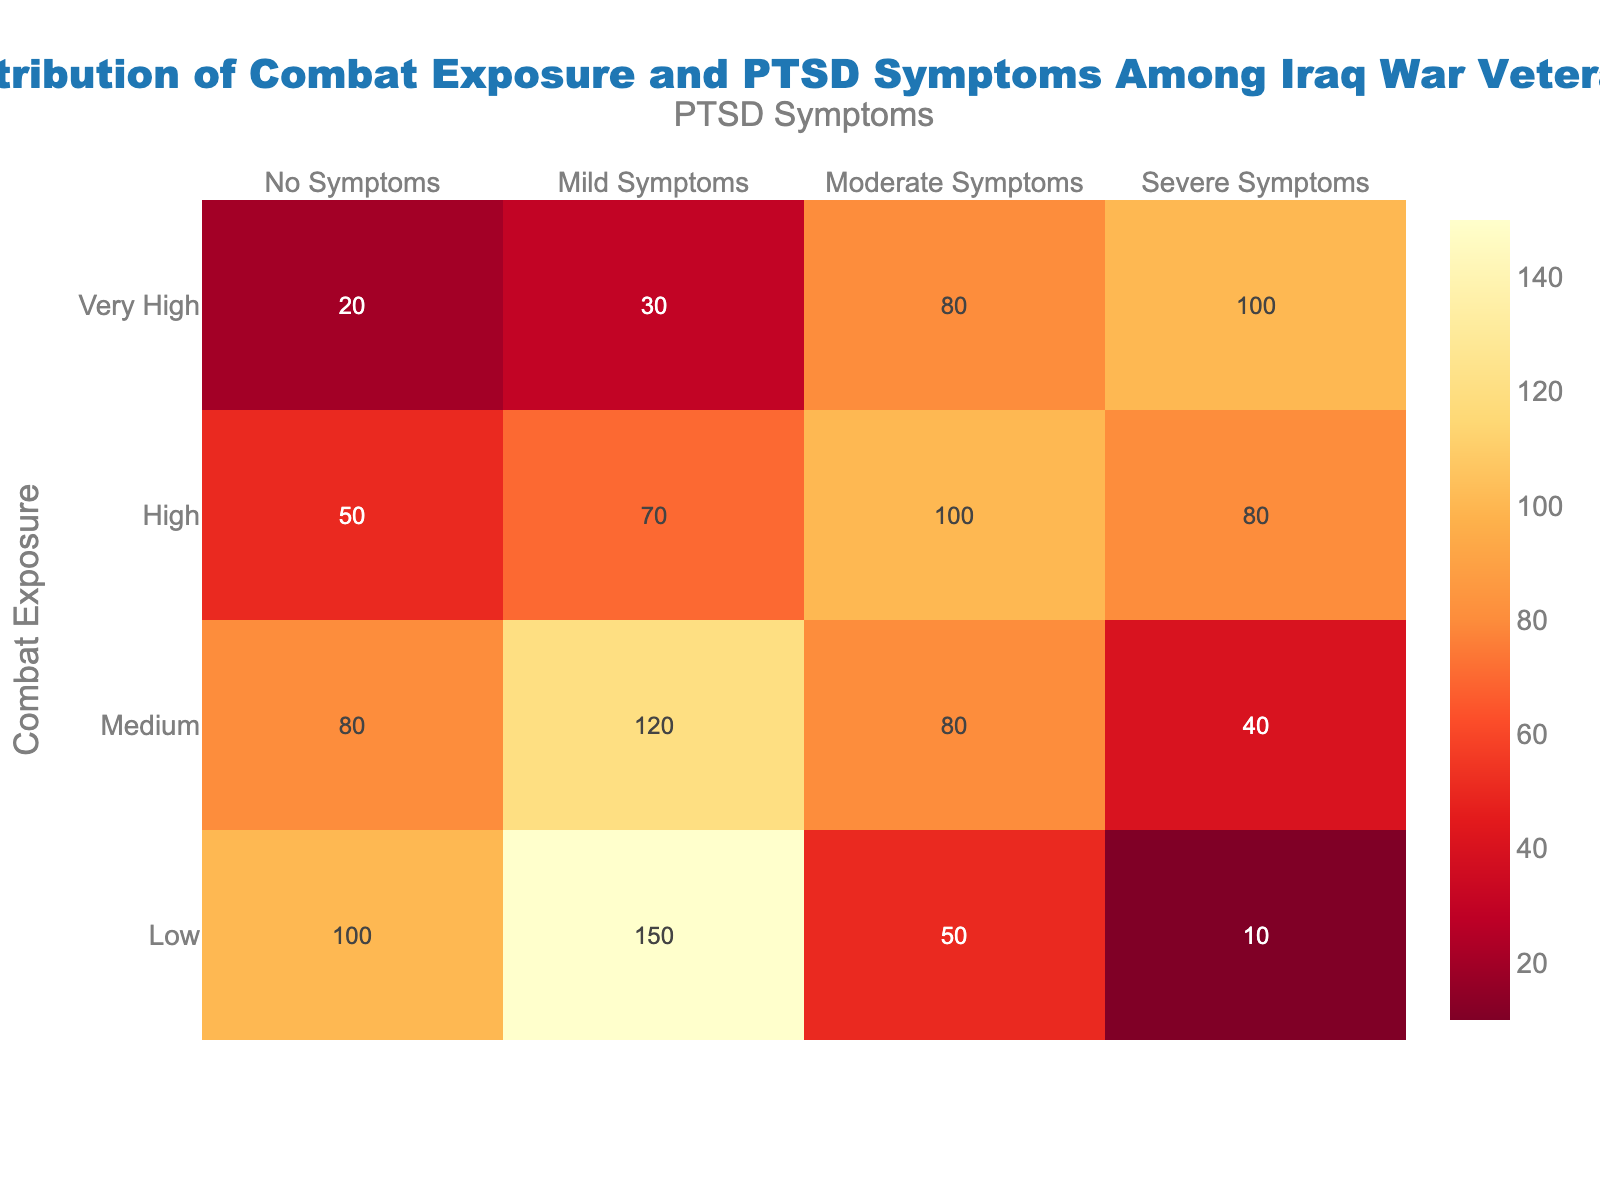what is the title of the heatmap? The title is located at the top of the figure and provides an overall description of the data being visualized. It reads "Distribution of Combat Exposure and PTSD Symptoms Among Iraq War Veterans."
Answer: Distribution of Combat Exposure and PTSD Symptoms Among Iraq War Veterans Which PTSD symptom category has the highest count for 'Low' combat exposure? In the row for 'Low' combat exposure, the number of veterans with 'Mild Symptoms' is the highest, as indicated by the value 150.
Answer: Mild Symptoms How many veterans experienced 'Severe Symptoms' with 'High' combat exposure? Looking at the 'High' combat exposure row, the number corresponding to 'Severe Symptoms' is 80.
Answer: 80 Compare the count of veterans with 'Moderate Symptoms' between 'Medium' and 'Very High' combat exposure. For 'Medium' combat exposure, the count is 80, while for 'Very High' it is also 80. Comparing these values shows they are equal.
Answer: They are equal What's the sum of veterans experiencing 'No Symptoms' across all levels of combat exposure? Add the values for 'No Symptoms' across all combat exposure levels: 100 (Low) + 80 (Medium) + 50 (High) + 20 (Very High) = 250.
Answer: 250 Which combat exposure level shows the highest overall count for any symptom category? The highest count in any category falls under 'Low' combat exposure with 'Mild Symptoms' at 150.
Answer: Low combat exposure in Mild Symptoms Calculate the total number of veterans with 'Mild Symptoms' and 'Moderate Symptoms' for 'Medium' combat exposure. Sum the values for 'Mild Symptoms' and 'Moderate Symptoms' under 'Medium' combat exposure: 120 (Mild) + 80 (Moderate) = 200.
Answer: 200 Is the number of veterans with 'Severe Symptoms' greater for 'Very High' combat exposure compared to 'High'? The number for 'Very High' is 100, while for 'High' it is 80. 100 is greater than 80.
Answer: Yes How does the number of veterans with 'No Symptoms' change as combat exposure level increases from 'Low' to 'Very High'? The numbers for 'No Symptoms' are: 'Low' - 100, 'Medium' - 80, 'High' - 50, 'Very High' - 20. There is a decreasing trend as exposure level increases.
Answer: Decreases Among all categories, which symptom level has the highest total number of veterans overall? Sum values across all combat exposure levels for each symptom category: No - 250, Mild - 370, Moderate - 310, Severe - 230. 'Mild Symptoms' has the highest total.
Answer: Mild Symptoms 